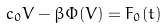Convert formula to latex. <formula><loc_0><loc_0><loc_500><loc_500>c _ { 0 } V - \beta \Phi ( V ) = F _ { 0 } ( t )</formula> 